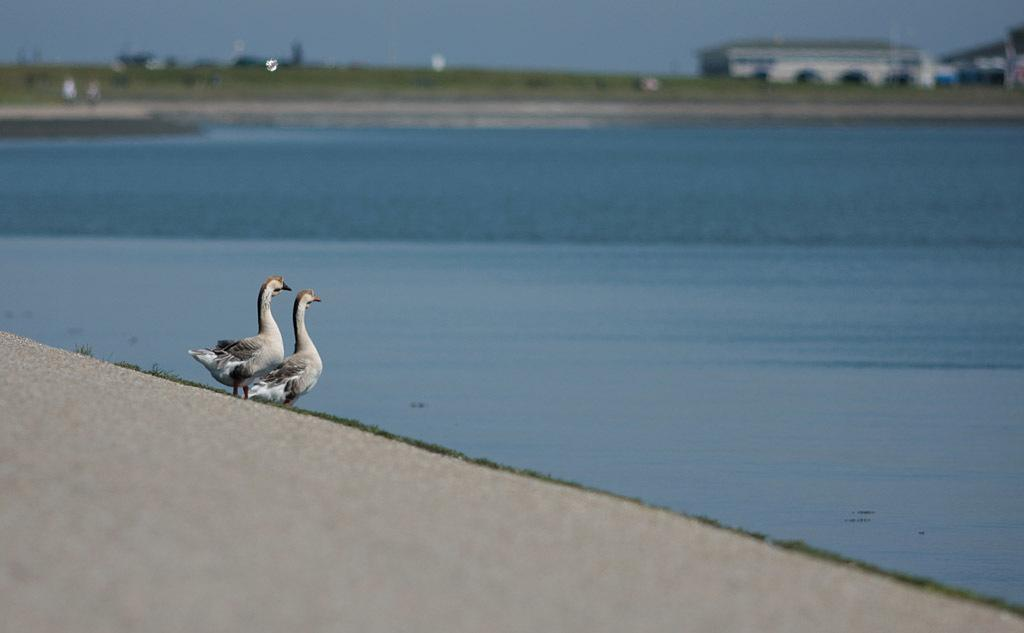What type of animals can be seen in the background of the image? There are two birds in the background of the image. What is the primary feature in the image? There is a water body in the image. What type of structures are visible in the background of the image? There are buildings in the background of the image. What part of the natural environment is visible in the image? The sky is visible in the background of the image. How would you describe the clarity of the background in the image? The background appears blurry. What is the relation between the birds and the water body in the image? There is no information about the relation between the birds and the water body in the image. How many pages are visible in the image? There are no pages present in the image. 